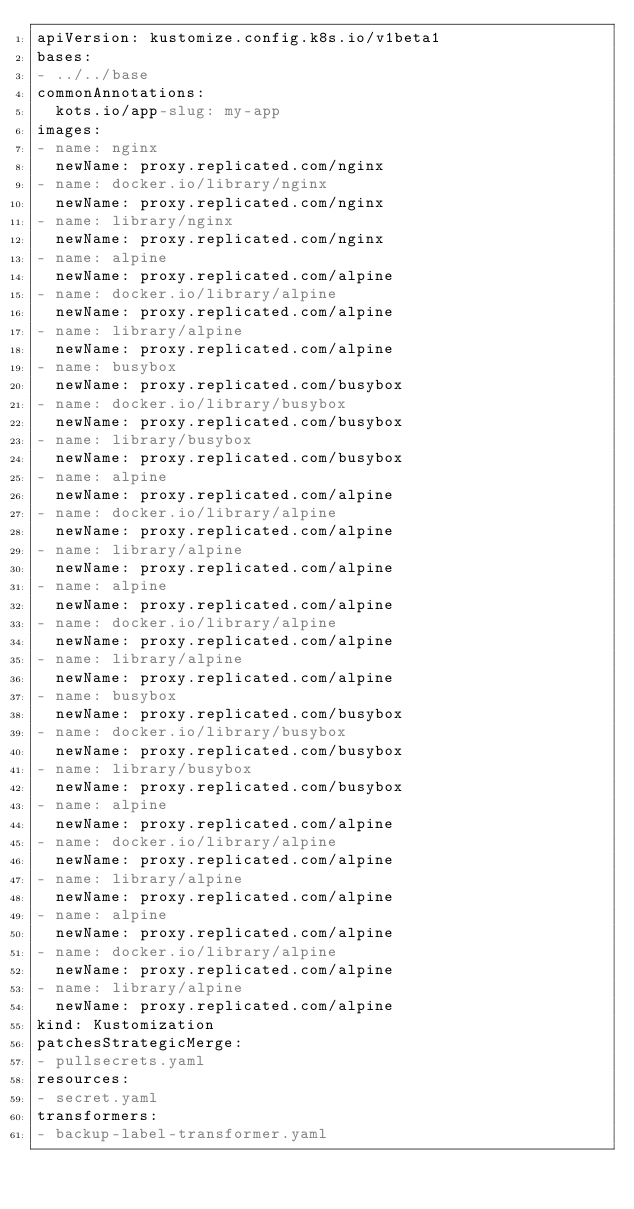<code> <loc_0><loc_0><loc_500><loc_500><_YAML_>apiVersion: kustomize.config.k8s.io/v1beta1
bases:
- ../../base
commonAnnotations:
  kots.io/app-slug: my-app
images:
- name: nginx
  newName: proxy.replicated.com/nginx
- name: docker.io/library/nginx
  newName: proxy.replicated.com/nginx
- name: library/nginx
  newName: proxy.replicated.com/nginx
- name: alpine
  newName: proxy.replicated.com/alpine
- name: docker.io/library/alpine
  newName: proxy.replicated.com/alpine
- name: library/alpine
  newName: proxy.replicated.com/alpine
- name: busybox
  newName: proxy.replicated.com/busybox
- name: docker.io/library/busybox
  newName: proxy.replicated.com/busybox
- name: library/busybox
  newName: proxy.replicated.com/busybox
- name: alpine
  newName: proxy.replicated.com/alpine
- name: docker.io/library/alpine
  newName: proxy.replicated.com/alpine
- name: library/alpine
  newName: proxy.replicated.com/alpine
- name: alpine
  newName: proxy.replicated.com/alpine
- name: docker.io/library/alpine
  newName: proxy.replicated.com/alpine
- name: library/alpine
  newName: proxy.replicated.com/alpine
- name: busybox
  newName: proxy.replicated.com/busybox
- name: docker.io/library/busybox
  newName: proxy.replicated.com/busybox
- name: library/busybox
  newName: proxy.replicated.com/busybox
- name: alpine
  newName: proxy.replicated.com/alpine
- name: docker.io/library/alpine
  newName: proxy.replicated.com/alpine
- name: library/alpine
  newName: proxy.replicated.com/alpine
- name: alpine
  newName: proxy.replicated.com/alpine
- name: docker.io/library/alpine
  newName: proxy.replicated.com/alpine
- name: library/alpine
  newName: proxy.replicated.com/alpine
kind: Kustomization
patchesStrategicMerge:
- pullsecrets.yaml
resources:
- secret.yaml
transformers:
- backup-label-transformer.yaml
</code> 